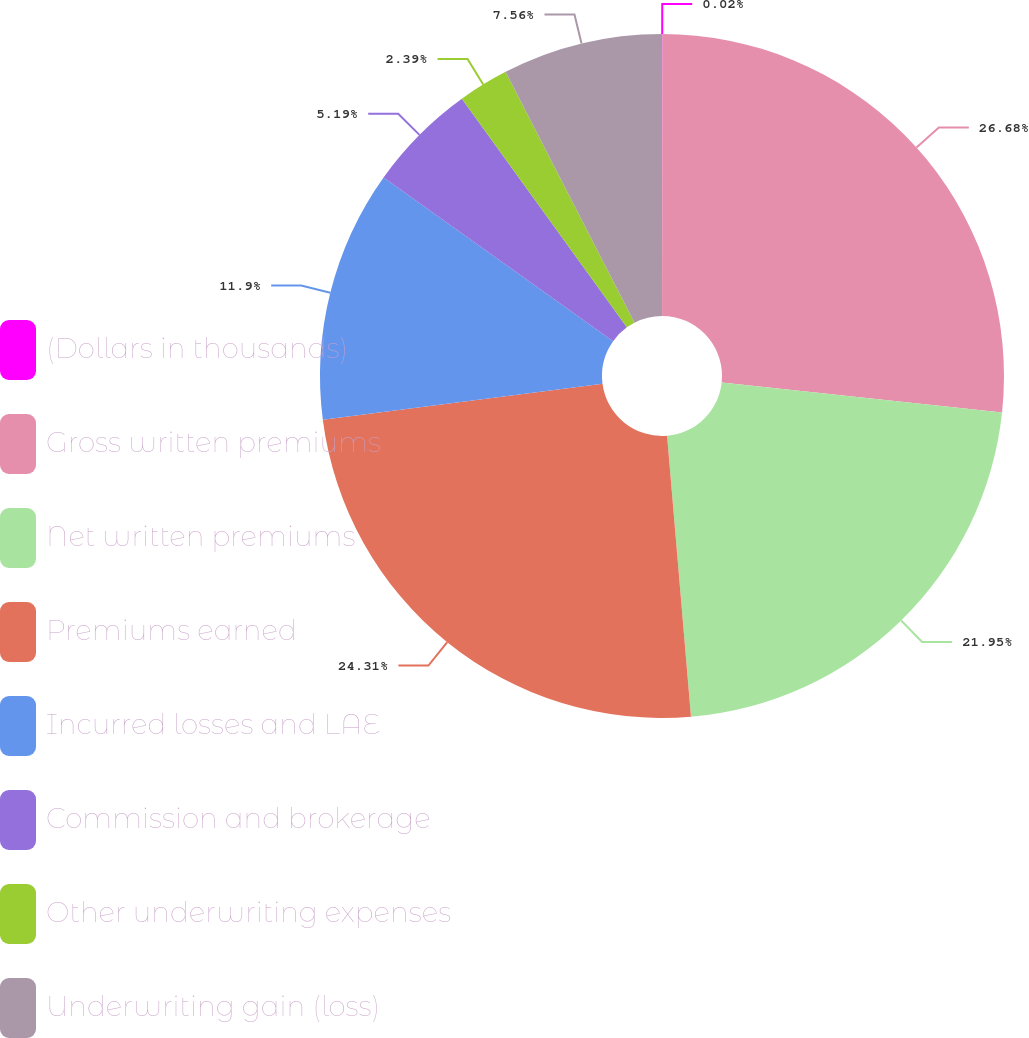<chart> <loc_0><loc_0><loc_500><loc_500><pie_chart><fcel>(Dollars in thousands)<fcel>Gross written premiums<fcel>Net written premiums<fcel>Premiums earned<fcel>Incurred losses and LAE<fcel>Commission and brokerage<fcel>Other underwriting expenses<fcel>Underwriting gain (loss)<nl><fcel>0.02%<fcel>26.68%<fcel>21.95%<fcel>24.31%<fcel>11.9%<fcel>5.19%<fcel>2.39%<fcel>7.56%<nl></chart> 